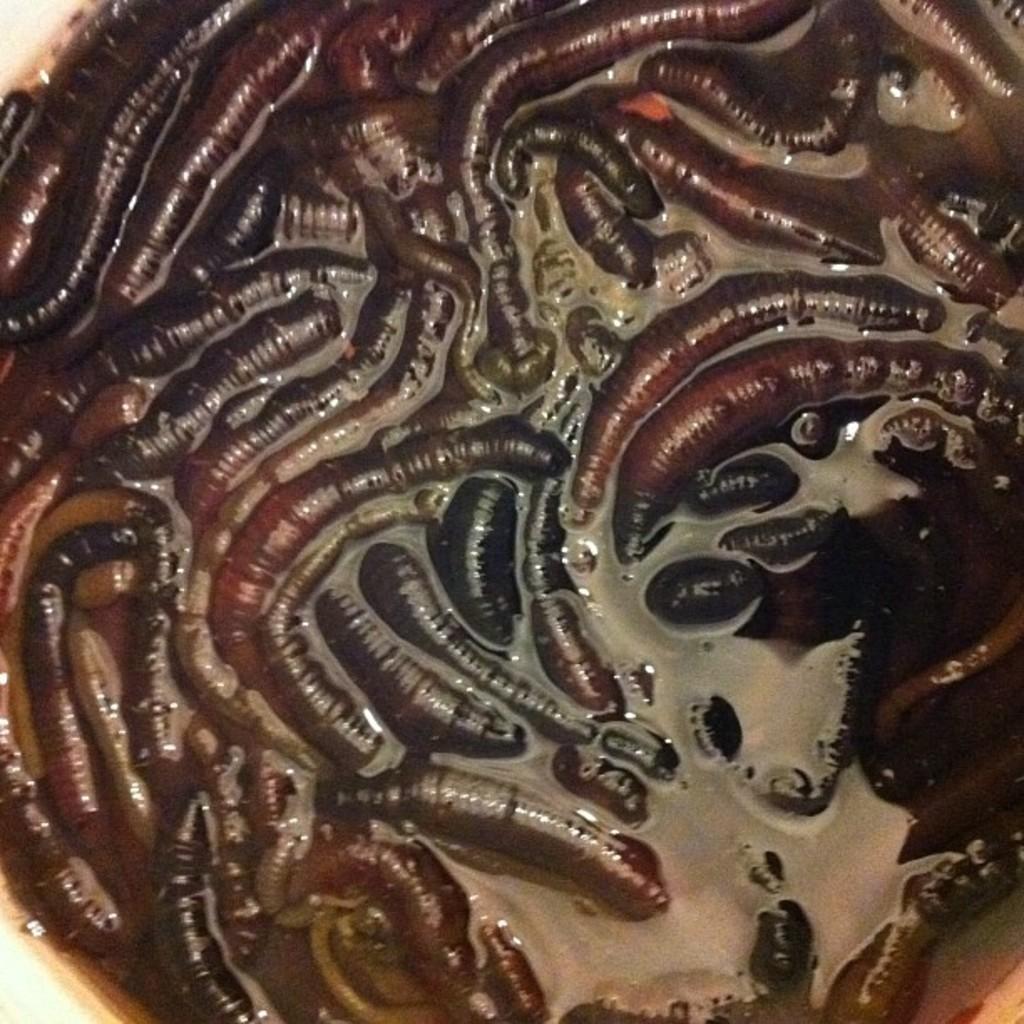How would you summarize this image in a sentence or two? In this image, there are some worms in a container. 